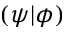<formula> <loc_0><loc_0><loc_500><loc_500>( \psi | \phi )</formula> 